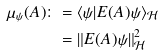<formula> <loc_0><loc_0><loc_500><loc_500>\mu _ { \psi } ( A ) \colon & = \langle \psi | E ( A ) \psi \rangle _ { \mathcal { H } } \\ & = \| E ( A ) \psi \| _ { \mathcal { H } } ^ { 2 }</formula> 